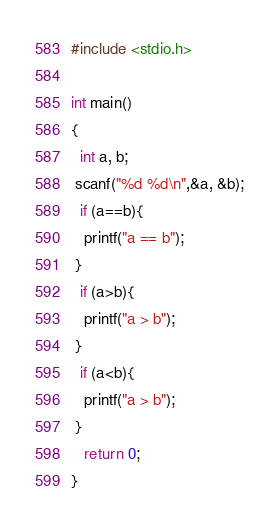<code> <loc_0><loc_0><loc_500><loc_500><_C_>#include <stdio.h>

int main()
{
  int a, b;
 scanf("%d %d\n",&a, &b);
  if (a==b){
   printf("a == b");
 }
  if (a>b){
   printf("a > b");
 }
  if (a<b){
   printf("a > b");
 }
   return 0;
}</code> 